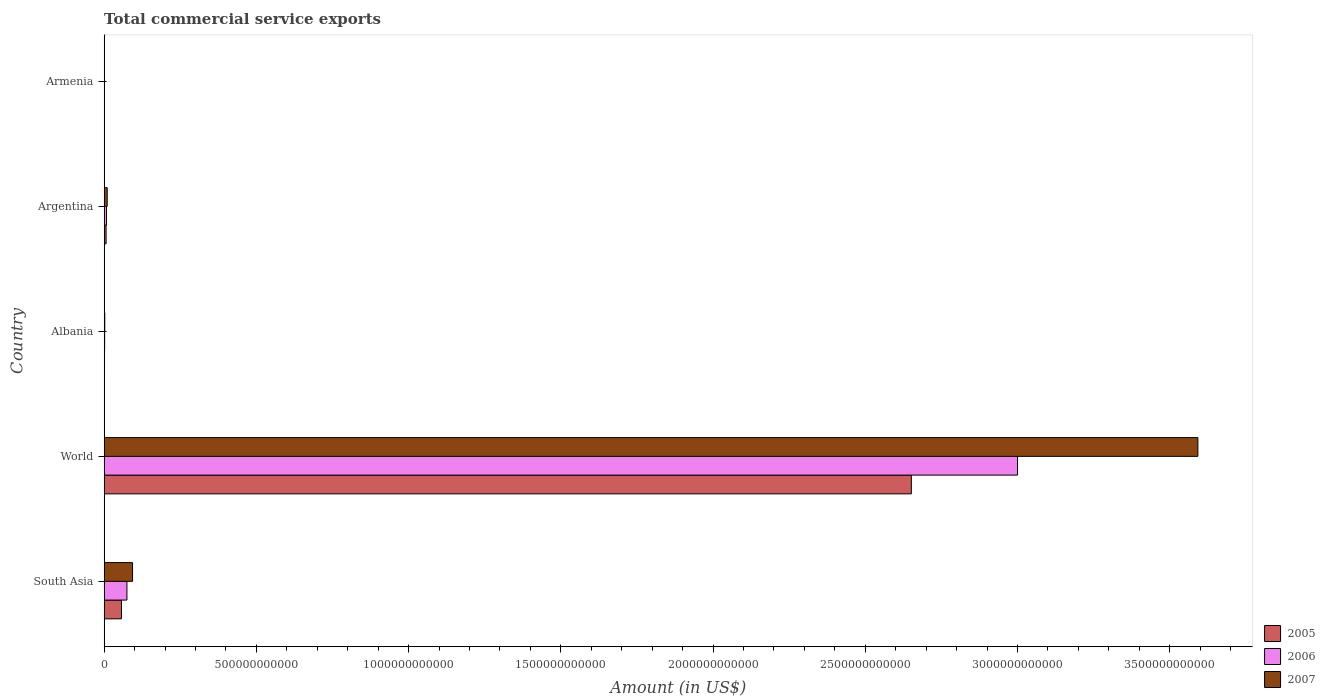How many different coloured bars are there?
Your response must be concise. 3. How many groups of bars are there?
Ensure brevity in your answer.  5. Are the number of bars on each tick of the Y-axis equal?
Offer a terse response. Yes. How many bars are there on the 4th tick from the bottom?
Offer a very short reply. 3. What is the total commercial service exports in 2005 in Albania?
Ensure brevity in your answer.  1.26e+09. Across all countries, what is the maximum total commercial service exports in 2005?
Make the answer very short. 2.65e+12. Across all countries, what is the minimum total commercial service exports in 2007?
Your response must be concise. 5.82e+08. In which country was the total commercial service exports in 2005 maximum?
Give a very brief answer. World. In which country was the total commercial service exports in 2007 minimum?
Your answer should be compact. Armenia. What is the total total commercial service exports in 2005 in the graph?
Give a very brief answer. 2.72e+12. What is the difference between the total commercial service exports in 2005 in Argentina and that in South Asia?
Ensure brevity in your answer.  -5.06e+1. What is the difference between the total commercial service exports in 2007 in South Asia and the total commercial service exports in 2005 in World?
Your answer should be compact. -2.56e+12. What is the average total commercial service exports in 2005 per country?
Make the answer very short. 5.43e+11. What is the difference between the total commercial service exports in 2006 and total commercial service exports in 2007 in World?
Your response must be concise. -5.92e+11. In how many countries, is the total commercial service exports in 2007 greater than 1600000000000 US$?
Provide a short and direct response. 1. What is the ratio of the total commercial service exports in 2005 in Albania to that in Armenia?
Provide a short and direct response. 2.98. What is the difference between the highest and the second highest total commercial service exports in 2007?
Make the answer very short. 3.50e+12. What is the difference between the highest and the lowest total commercial service exports in 2007?
Ensure brevity in your answer.  3.59e+12. In how many countries, is the total commercial service exports in 2005 greater than the average total commercial service exports in 2005 taken over all countries?
Make the answer very short. 1. What does the 1st bar from the top in World represents?
Your answer should be compact. 2007. Is it the case that in every country, the sum of the total commercial service exports in 2006 and total commercial service exports in 2007 is greater than the total commercial service exports in 2005?
Make the answer very short. Yes. How many bars are there?
Ensure brevity in your answer.  15. How many countries are there in the graph?
Offer a terse response. 5. What is the difference between two consecutive major ticks on the X-axis?
Offer a terse response. 5.00e+11. Are the values on the major ticks of X-axis written in scientific E-notation?
Your response must be concise. No. Does the graph contain any zero values?
Keep it short and to the point. No. Does the graph contain grids?
Offer a terse response. No. How many legend labels are there?
Offer a terse response. 3. What is the title of the graph?
Ensure brevity in your answer.  Total commercial service exports. What is the label or title of the X-axis?
Give a very brief answer. Amount (in US$). What is the Amount (in US$) in 2005 in South Asia?
Your answer should be compact. 5.69e+1. What is the Amount (in US$) of 2006 in South Asia?
Offer a terse response. 7.48e+1. What is the Amount (in US$) of 2007 in South Asia?
Your answer should be compact. 9.33e+1. What is the Amount (in US$) in 2005 in World?
Offer a terse response. 2.65e+12. What is the Amount (in US$) in 2006 in World?
Your response must be concise. 3.00e+12. What is the Amount (in US$) in 2007 in World?
Give a very brief answer. 3.59e+12. What is the Amount (in US$) of 2005 in Albania?
Your response must be concise. 1.26e+09. What is the Amount (in US$) of 2006 in Albania?
Your answer should be compact. 1.62e+09. What is the Amount (in US$) in 2007 in Albania?
Offer a terse response. 2.08e+09. What is the Amount (in US$) of 2005 in Argentina?
Keep it short and to the point. 6.34e+09. What is the Amount (in US$) in 2006 in Argentina?
Your answer should be very brief. 7.71e+09. What is the Amount (in US$) of 2007 in Argentina?
Your answer should be very brief. 1.00e+1. What is the Amount (in US$) in 2005 in Armenia?
Keep it short and to the point. 4.22e+08. What is the Amount (in US$) in 2006 in Armenia?
Ensure brevity in your answer.  4.87e+08. What is the Amount (in US$) in 2007 in Armenia?
Make the answer very short. 5.82e+08. Across all countries, what is the maximum Amount (in US$) of 2005?
Keep it short and to the point. 2.65e+12. Across all countries, what is the maximum Amount (in US$) in 2006?
Your answer should be compact. 3.00e+12. Across all countries, what is the maximum Amount (in US$) in 2007?
Your answer should be compact. 3.59e+12. Across all countries, what is the minimum Amount (in US$) in 2005?
Your answer should be compact. 4.22e+08. Across all countries, what is the minimum Amount (in US$) in 2006?
Ensure brevity in your answer.  4.87e+08. Across all countries, what is the minimum Amount (in US$) in 2007?
Your response must be concise. 5.82e+08. What is the total Amount (in US$) of 2005 in the graph?
Your answer should be very brief. 2.72e+12. What is the total Amount (in US$) of 2006 in the graph?
Provide a short and direct response. 3.08e+12. What is the total Amount (in US$) of 2007 in the graph?
Your answer should be very brief. 3.70e+12. What is the difference between the Amount (in US$) of 2005 in South Asia and that in World?
Provide a succinct answer. -2.59e+12. What is the difference between the Amount (in US$) in 2006 in South Asia and that in World?
Provide a short and direct response. -2.93e+12. What is the difference between the Amount (in US$) in 2007 in South Asia and that in World?
Provide a succinct answer. -3.50e+12. What is the difference between the Amount (in US$) of 2005 in South Asia and that in Albania?
Ensure brevity in your answer.  5.57e+1. What is the difference between the Amount (in US$) of 2006 in South Asia and that in Albania?
Offer a terse response. 7.32e+1. What is the difference between the Amount (in US$) of 2007 in South Asia and that in Albania?
Your response must be concise. 9.12e+1. What is the difference between the Amount (in US$) in 2005 in South Asia and that in Argentina?
Ensure brevity in your answer.  5.06e+1. What is the difference between the Amount (in US$) in 2006 in South Asia and that in Argentina?
Offer a very short reply. 6.71e+1. What is the difference between the Amount (in US$) of 2007 in South Asia and that in Argentina?
Provide a succinct answer. 8.33e+1. What is the difference between the Amount (in US$) in 2005 in South Asia and that in Armenia?
Your response must be concise. 5.65e+1. What is the difference between the Amount (in US$) in 2006 in South Asia and that in Armenia?
Provide a succinct answer. 7.43e+1. What is the difference between the Amount (in US$) in 2007 in South Asia and that in Armenia?
Provide a short and direct response. 9.27e+1. What is the difference between the Amount (in US$) of 2005 in World and that in Albania?
Provide a succinct answer. 2.65e+12. What is the difference between the Amount (in US$) of 2006 in World and that in Albania?
Give a very brief answer. 3.00e+12. What is the difference between the Amount (in US$) of 2007 in World and that in Albania?
Give a very brief answer. 3.59e+12. What is the difference between the Amount (in US$) in 2005 in World and that in Argentina?
Offer a very short reply. 2.64e+12. What is the difference between the Amount (in US$) of 2006 in World and that in Argentina?
Your answer should be very brief. 2.99e+12. What is the difference between the Amount (in US$) of 2007 in World and that in Argentina?
Offer a terse response. 3.58e+12. What is the difference between the Amount (in US$) in 2005 in World and that in Armenia?
Provide a succinct answer. 2.65e+12. What is the difference between the Amount (in US$) in 2006 in World and that in Armenia?
Give a very brief answer. 3.00e+12. What is the difference between the Amount (in US$) of 2007 in World and that in Armenia?
Your answer should be very brief. 3.59e+12. What is the difference between the Amount (in US$) of 2005 in Albania and that in Argentina?
Give a very brief answer. -5.09e+09. What is the difference between the Amount (in US$) in 2006 in Albania and that in Argentina?
Keep it short and to the point. -6.09e+09. What is the difference between the Amount (in US$) in 2007 in Albania and that in Argentina?
Offer a very short reply. -7.92e+09. What is the difference between the Amount (in US$) of 2005 in Albania and that in Armenia?
Provide a short and direct response. 8.34e+08. What is the difference between the Amount (in US$) in 2006 in Albania and that in Armenia?
Provide a short and direct response. 1.14e+09. What is the difference between the Amount (in US$) in 2007 in Albania and that in Armenia?
Offer a very short reply. 1.50e+09. What is the difference between the Amount (in US$) of 2005 in Argentina and that in Armenia?
Offer a terse response. 5.92e+09. What is the difference between the Amount (in US$) of 2006 in Argentina and that in Armenia?
Offer a terse response. 7.23e+09. What is the difference between the Amount (in US$) in 2007 in Argentina and that in Armenia?
Your answer should be very brief. 9.42e+09. What is the difference between the Amount (in US$) in 2005 in South Asia and the Amount (in US$) in 2006 in World?
Give a very brief answer. -2.94e+12. What is the difference between the Amount (in US$) of 2005 in South Asia and the Amount (in US$) of 2007 in World?
Your answer should be very brief. -3.54e+12. What is the difference between the Amount (in US$) of 2006 in South Asia and the Amount (in US$) of 2007 in World?
Keep it short and to the point. -3.52e+12. What is the difference between the Amount (in US$) of 2005 in South Asia and the Amount (in US$) of 2006 in Albania?
Keep it short and to the point. 5.53e+1. What is the difference between the Amount (in US$) in 2005 in South Asia and the Amount (in US$) in 2007 in Albania?
Provide a short and direct response. 5.48e+1. What is the difference between the Amount (in US$) of 2006 in South Asia and the Amount (in US$) of 2007 in Albania?
Your answer should be compact. 7.27e+1. What is the difference between the Amount (in US$) in 2005 in South Asia and the Amount (in US$) in 2006 in Argentina?
Make the answer very short. 4.92e+1. What is the difference between the Amount (in US$) in 2005 in South Asia and the Amount (in US$) in 2007 in Argentina?
Make the answer very short. 4.69e+1. What is the difference between the Amount (in US$) in 2006 in South Asia and the Amount (in US$) in 2007 in Argentina?
Your response must be concise. 6.48e+1. What is the difference between the Amount (in US$) of 2005 in South Asia and the Amount (in US$) of 2006 in Armenia?
Give a very brief answer. 5.64e+1. What is the difference between the Amount (in US$) in 2005 in South Asia and the Amount (in US$) in 2007 in Armenia?
Offer a very short reply. 5.63e+1. What is the difference between the Amount (in US$) of 2006 in South Asia and the Amount (in US$) of 2007 in Armenia?
Your answer should be compact. 7.42e+1. What is the difference between the Amount (in US$) in 2005 in World and the Amount (in US$) in 2006 in Albania?
Offer a very short reply. 2.65e+12. What is the difference between the Amount (in US$) in 2005 in World and the Amount (in US$) in 2007 in Albania?
Provide a short and direct response. 2.65e+12. What is the difference between the Amount (in US$) of 2006 in World and the Amount (in US$) of 2007 in Albania?
Ensure brevity in your answer.  3.00e+12. What is the difference between the Amount (in US$) in 2005 in World and the Amount (in US$) in 2006 in Argentina?
Offer a very short reply. 2.64e+12. What is the difference between the Amount (in US$) in 2005 in World and the Amount (in US$) in 2007 in Argentina?
Keep it short and to the point. 2.64e+12. What is the difference between the Amount (in US$) of 2006 in World and the Amount (in US$) of 2007 in Argentina?
Make the answer very short. 2.99e+12. What is the difference between the Amount (in US$) in 2005 in World and the Amount (in US$) in 2006 in Armenia?
Your answer should be very brief. 2.65e+12. What is the difference between the Amount (in US$) in 2005 in World and the Amount (in US$) in 2007 in Armenia?
Offer a very short reply. 2.65e+12. What is the difference between the Amount (in US$) in 2006 in World and the Amount (in US$) in 2007 in Armenia?
Make the answer very short. 3.00e+12. What is the difference between the Amount (in US$) in 2005 in Albania and the Amount (in US$) in 2006 in Argentina?
Provide a short and direct response. -6.46e+09. What is the difference between the Amount (in US$) of 2005 in Albania and the Amount (in US$) of 2007 in Argentina?
Offer a very short reply. -8.75e+09. What is the difference between the Amount (in US$) of 2006 in Albania and the Amount (in US$) of 2007 in Argentina?
Your response must be concise. -8.38e+09. What is the difference between the Amount (in US$) of 2005 in Albania and the Amount (in US$) of 2006 in Armenia?
Your answer should be compact. 7.69e+08. What is the difference between the Amount (in US$) in 2005 in Albania and the Amount (in US$) in 2007 in Armenia?
Give a very brief answer. 6.75e+08. What is the difference between the Amount (in US$) in 2006 in Albania and the Amount (in US$) in 2007 in Armenia?
Keep it short and to the point. 1.04e+09. What is the difference between the Amount (in US$) of 2005 in Argentina and the Amount (in US$) of 2006 in Armenia?
Provide a short and direct response. 5.86e+09. What is the difference between the Amount (in US$) of 2005 in Argentina and the Amount (in US$) of 2007 in Armenia?
Your response must be concise. 5.76e+09. What is the difference between the Amount (in US$) in 2006 in Argentina and the Amount (in US$) in 2007 in Armenia?
Give a very brief answer. 7.13e+09. What is the average Amount (in US$) in 2005 per country?
Offer a very short reply. 5.43e+11. What is the average Amount (in US$) of 2006 per country?
Offer a very short reply. 6.17e+11. What is the average Amount (in US$) of 2007 per country?
Ensure brevity in your answer.  7.40e+11. What is the difference between the Amount (in US$) in 2005 and Amount (in US$) in 2006 in South Asia?
Offer a terse response. -1.79e+1. What is the difference between the Amount (in US$) of 2005 and Amount (in US$) of 2007 in South Asia?
Make the answer very short. -3.64e+1. What is the difference between the Amount (in US$) in 2006 and Amount (in US$) in 2007 in South Asia?
Provide a succinct answer. -1.85e+1. What is the difference between the Amount (in US$) in 2005 and Amount (in US$) in 2006 in World?
Ensure brevity in your answer.  -3.49e+11. What is the difference between the Amount (in US$) in 2005 and Amount (in US$) in 2007 in World?
Ensure brevity in your answer.  -9.41e+11. What is the difference between the Amount (in US$) of 2006 and Amount (in US$) of 2007 in World?
Offer a terse response. -5.92e+11. What is the difference between the Amount (in US$) in 2005 and Amount (in US$) in 2006 in Albania?
Make the answer very short. -3.67e+08. What is the difference between the Amount (in US$) in 2005 and Amount (in US$) in 2007 in Albania?
Provide a succinct answer. -8.26e+08. What is the difference between the Amount (in US$) of 2006 and Amount (in US$) of 2007 in Albania?
Keep it short and to the point. -4.59e+08. What is the difference between the Amount (in US$) in 2005 and Amount (in US$) in 2006 in Argentina?
Keep it short and to the point. -1.37e+09. What is the difference between the Amount (in US$) in 2005 and Amount (in US$) in 2007 in Argentina?
Your response must be concise. -3.66e+09. What is the difference between the Amount (in US$) in 2006 and Amount (in US$) in 2007 in Argentina?
Make the answer very short. -2.29e+09. What is the difference between the Amount (in US$) of 2005 and Amount (in US$) of 2006 in Armenia?
Keep it short and to the point. -6.57e+07. What is the difference between the Amount (in US$) in 2005 and Amount (in US$) in 2007 in Armenia?
Give a very brief answer. -1.60e+08. What is the difference between the Amount (in US$) in 2006 and Amount (in US$) in 2007 in Armenia?
Make the answer very short. -9.43e+07. What is the ratio of the Amount (in US$) of 2005 in South Asia to that in World?
Offer a very short reply. 0.02. What is the ratio of the Amount (in US$) in 2006 in South Asia to that in World?
Your answer should be compact. 0.02. What is the ratio of the Amount (in US$) of 2007 in South Asia to that in World?
Provide a short and direct response. 0.03. What is the ratio of the Amount (in US$) of 2005 in South Asia to that in Albania?
Provide a short and direct response. 45.3. What is the ratio of the Amount (in US$) in 2006 in South Asia to that in Albania?
Your answer should be compact. 46.1. What is the ratio of the Amount (in US$) of 2007 in South Asia to that in Albania?
Offer a very short reply. 44.79. What is the ratio of the Amount (in US$) of 2005 in South Asia to that in Argentina?
Your response must be concise. 8.97. What is the ratio of the Amount (in US$) in 2006 in South Asia to that in Argentina?
Provide a succinct answer. 9.7. What is the ratio of the Amount (in US$) of 2007 in South Asia to that in Argentina?
Your answer should be compact. 9.32. What is the ratio of the Amount (in US$) in 2005 in South Asia to that in Armenia?
Keep it short and to the point. 134.93. What is the ratio of the Amount (in US$) of 2006 in South Asia to that in Armenia?
Keep it short and to the point. 153.51. What is the ratio of the Amount (in US$) in 2007 in South Asia to that in Armenia?
Offer a very short reply. 160.36. What is the ratio of the Amount (in US$) of 2005 in World to that in Albania?
Make the answer very short. 2110.43. What is the ratio of the Amount (in US$) of 2006 in World to that in Albania?
Your answer should be very brief. 1848.32. What is the ratio of the Amount (in US$) in 2007 in World to that in Albania?
Give a very brief answer. 1724.98. What is the ratio of the Amount (in US$) in 2005 in World to that in Argentina?
Ensure brevity in your answer.  417.99. What is the ratio of the Amount (in US$) in 2006 in World to that in Argentina?
Make the answer very short. 388.92. What is the ratio of the Amount (in US$) in 2007 in World to that in Argentina?
Keep it short and to the point. 359. What is the ratio of the Amount (in US$) in 2005 in World to that in Armenia?
Ensure brevity in your answer.  6285.44. What is the ratio of the Amount (in US$) of 2006 in World to that in Armenia?
Offer a terse response. 6154.1. What is the ratio of the Amount (in US$) of 2007 in World to that in Armenia?
Keep it short and to the point. 6175.11. What is the ratio of the Amount (in US$) of 2005 in Albania to that in Argentina?
Give a very brief answer. 0.2. What is the ratio of the Amount (in US$) of 2006 in Albania to that in Argentina?
Offer a very short reply. 0.21. What is the ratio of the Amount (in US$) of 2007 in Albania to that in Argentina?
Give a very brief answer. 0.21. What is the ratio of the Amount (in US$) in 2005 in Albania to that in Armenia?
Provide a short and direct response. 2.98. What is the ratio of the Amount (in US$) in 2006 in Albania to that in Armenia?
Your response must be concise. 3.33. What is the ratio of the Amount (in US$) of 2007 in Albania to that in Armenia?
Your response must be concise. 3.58. What is the ratio of the Amount (in US$) of 2005 in Argentina to that in Armenia?
Provide a succinct answer. 15.04. What is the ratio of the Amount (in US$) in 2006 in Argentina to that in Armenia?
Provide a short and direct response. 15.82. What is the ratio of the Amount (in US$) of 2007 in Argentina to that in Armenia?
Your answer should be compact. 17.2. What is the difference between the highest and the second highest Amount (in US$) in 2005?
Ensure brevity in your answer.  2.59e+12. What is the difference between the highest and the second highest Amount (in US$) in 2006?
Keep it short and to the point. 2.93e+12. What is the difference between the highest and the second highest Amount (in US$) in 2007?
Give a very brief answer. 3.50e+12. What is the difference between the highest and the lowest Amount (in US$) of 2005?
Offer a terse response. 2.65e+12. What is the difference between the highest and the lowest Amount (in US$) of 2006?
Your answer should be very brief. 3.00e+12. What is the difference between the highest and the lowest Amount (in US$) in 2007?
Your response must be concise. 3.59e+12. 